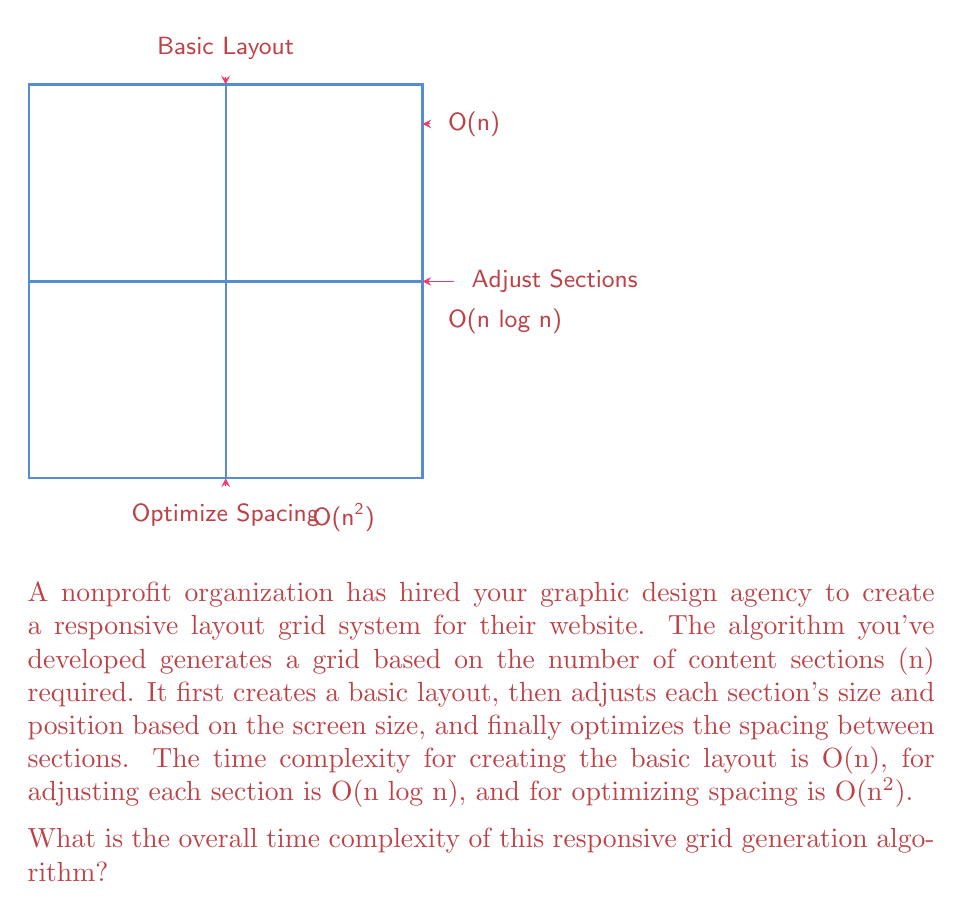Help me with this question. To determine the overall time complexity of the algorithm, we need to consider the time complexities of each step and identify the dominant term. Let's break it down step-by-step:

1. Creating the basic layout: O(n)
2. Adjusting each section: O(n log n)
3. Optimizing spacing: O(n^2)

To find the overall time complexity, we add these terms together:

$$ O(n) + O(n \log n) + O(n^2) $$

Now, we need to identify the dominant term. In algorithm analysis, we focus on the term that grows the fastest as n increases. We can compare the growth rates:

- O(n) grows linearly
- O(n log n) grows slightly faster than linear
- O(n^2) grows quadratically

Among these, O(n^2) grows the fastest for large values of n. Therefore, it dominates the other terms.

When we have a sum of different time complexities, we can simplify by keeping only the dominant term. This is because as n becomes very large, the contribution of the lower-order terms becomes negligible compared to the highest-order term.

Thus, we can simplify the overall time complexity to:

$$ O(n^2) $$

This means that for large inputs, the time taken by the algorithm will grow quadratically with the number of content sections (n).
Answer: O(n^2) 